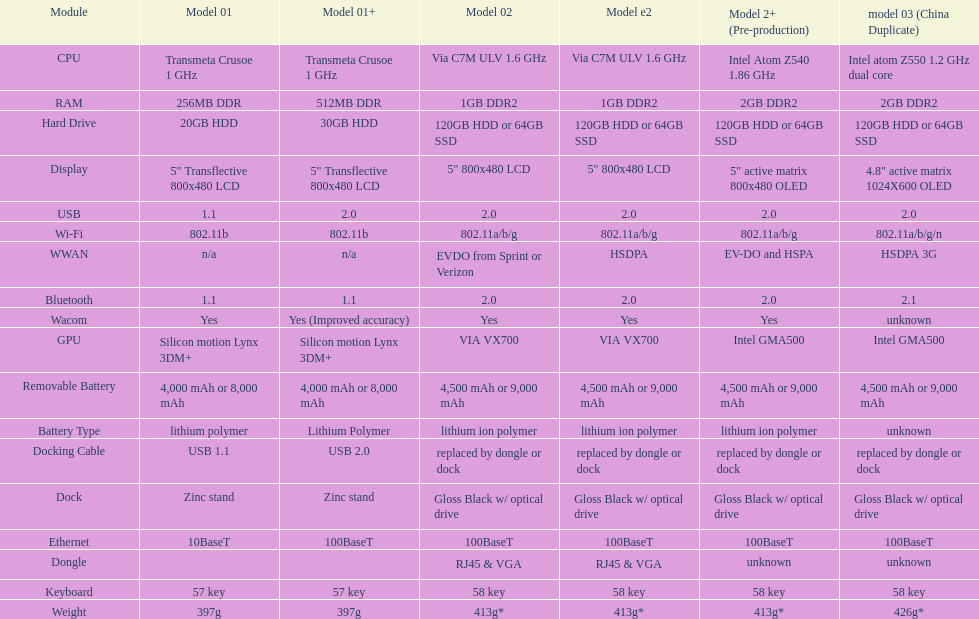Which model provides a larger hard drive: model 01 or model 02? Model 02. 